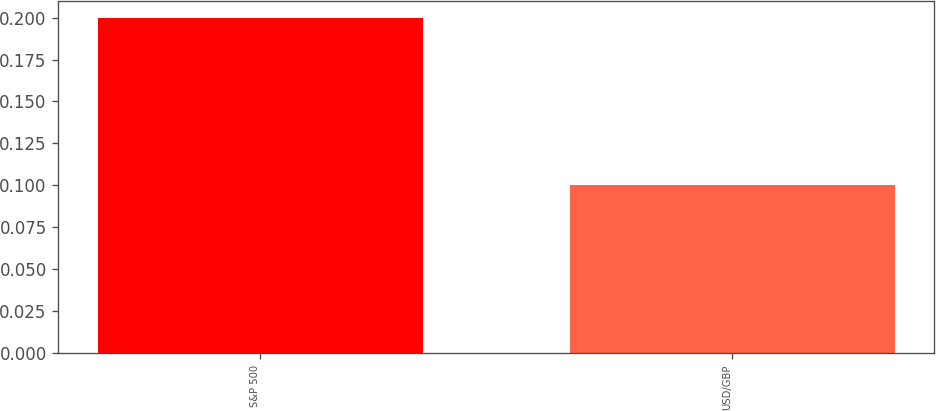<chart> <loc_0><loc_0><loc_500><loc_500><bar_chart><fcel>S&P 500<fcel>USD/GBP<nl><fcel>0.2<fcel>0.1<nl></chart> 